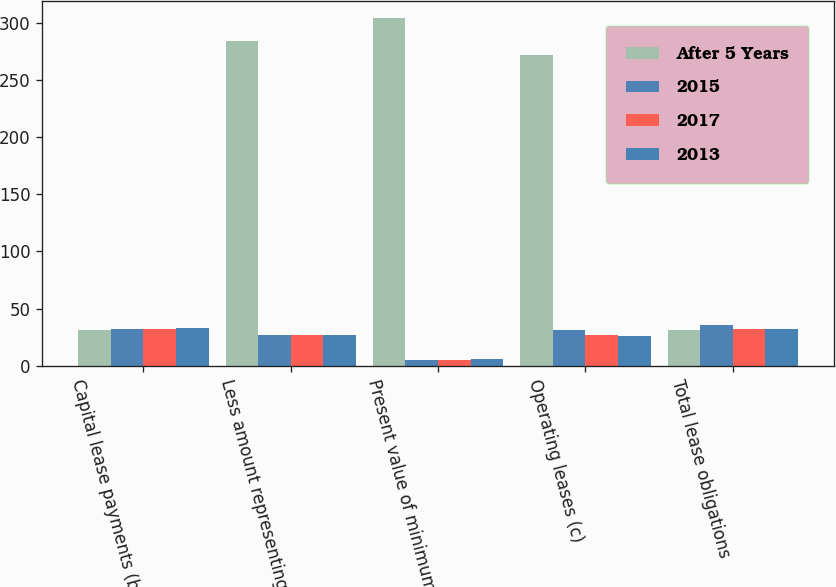Convert chart to OTSL. <chart><loc_0><loc_0><loc_500><loc_500><stacked_bar_chart><ecel><fcel>Capital lease payments (b)<fcel>Less amount representing<fcel>Present value of minimum<fcel>Operating leases (c)<fcel>Total lease obligations<nl><fcel>After 5 Years<fcel>31.5<fcel>284<fcel>304<fcel>272<fcel>31.5<nl><fcel>2015<fcel>32<fcel>27<fcel>5<fcel>31<fcel>36<nl><fcel>2017<fcel>32<fcel>27<fcel>5<fcel>27<fcel>32<nl><fcel>2013<fcel>33<fcel>27<fcel>6<fcel>26<fcel>32<nl></chart> 